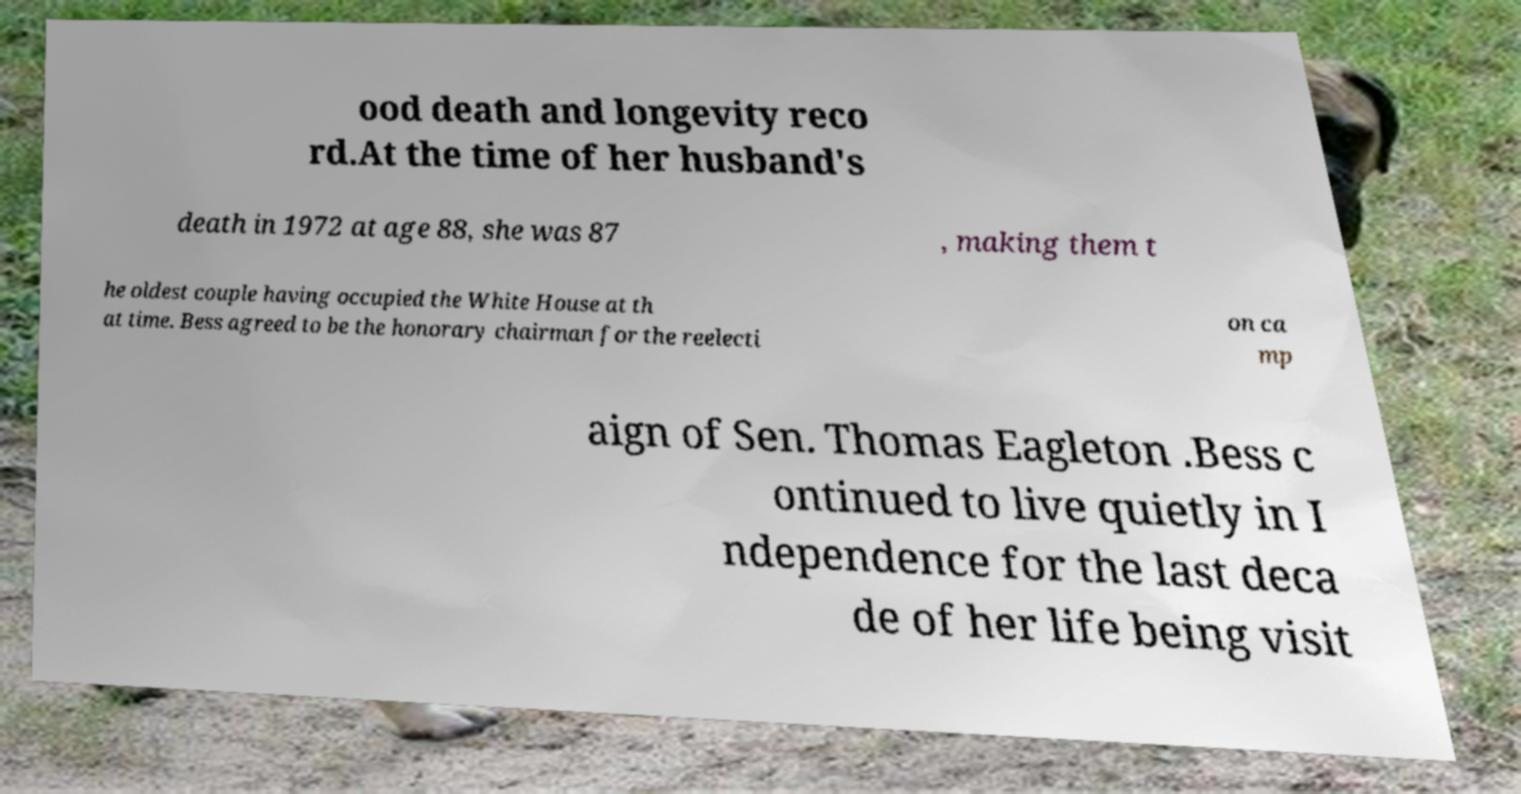Can you read and provide the text displayed in the image?This photo seems to have some interesting text. Can you extract and type it out for me? ood death and longevity reco rd.At the time of her husband's death in 1972 at age 88, she was 87 , making them t he oldest couple having occupied the White House at th at time. Bess agreed to be the honorary chairman for the reelecti on ca mp aign of Sen. Thomas Eagleton .Bess c ontinued to live quietly in I ndependence for the last deca de of her life being visit 